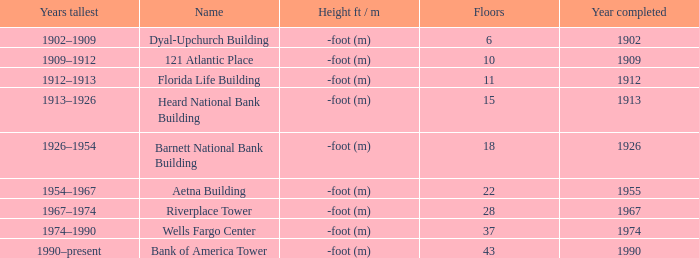How tall is the florida life building, completed before 1990? -foot (m). 